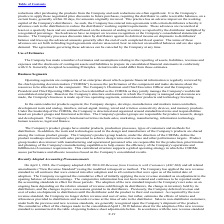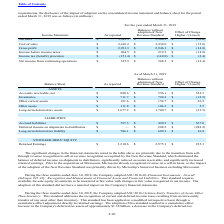According to Microchip Technology's financial document, What was the main reason given by the company for the significant changes in their financial statements noted in the table? Based on the financial document, the answer is the transition from sellthrough revenue recognition to sell-in revenue recognition as required by the New Revenue Standard. Also, What was the effect of change in the net accounts receivable? According to the financial document, 324.5 (in millions). The relevant text states: "Accounts receivable, net $ 880.6 $ 556.1 $ 324.5..." Also, What was the reported amount of inventories? According to the financial document, 711.7 (in millions). The relevant text states: "Inventories $ 711.7 $ 724.2 $ (12.5)..." Also, can you calculate: What was the difference in reported amounts between net accounts receivable and inventories? Based on the calculation: 880.6-711.7, the result is 168.9 (in millions). This is based on the information: "Inventories $ 711.7 $ 724.2 $ (12.5) Accounts receivable, net $ 880.6 $ 556.1 $ 324.5..." The key data points involved are: 711.7, 880.6. Also, can you calculate: What was the difference in reported amount between other assets and other current assets? Based on the calculation: 191.6-111.8, the result is 79.8 (in millions). This is based on the information: "Other current assets $ 191.6 $ 154.7 $ 36.9 Other assets $ 111.8 $ 106.3 $ 5.5..." The key data points involved are: 111.8, 191.6. Also, can you calculate: What was the Long-term deferred tax liability as a ratio of Accrued liabilities? Based on the calculation: 706.1/787.3, the result is 89.69 (percentage). This is based on the information: "Long-term deferred tax liability $ 706.1 $ 689.3 $ 16.8 Accrued liabilities $ 787.3 $ 420.3 $ 367.0..." The key data points involved are: 706.1, 787.3. 